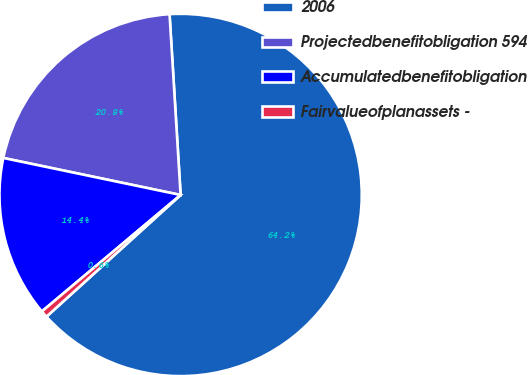Convert chart to OTSL. <chart><loc_0><loc_0><loc_500><loc_500><pie_chart><fcel>2006<fcel>Projectedbenefitobligation 594<fcel>Accumulatedbenefitobligation<fcel>Fairvalueofplanassets -<nl><fcel>64.25%<fcel>20.75%<fcel>14.39%<fcel>0.61%<nl></chart> 